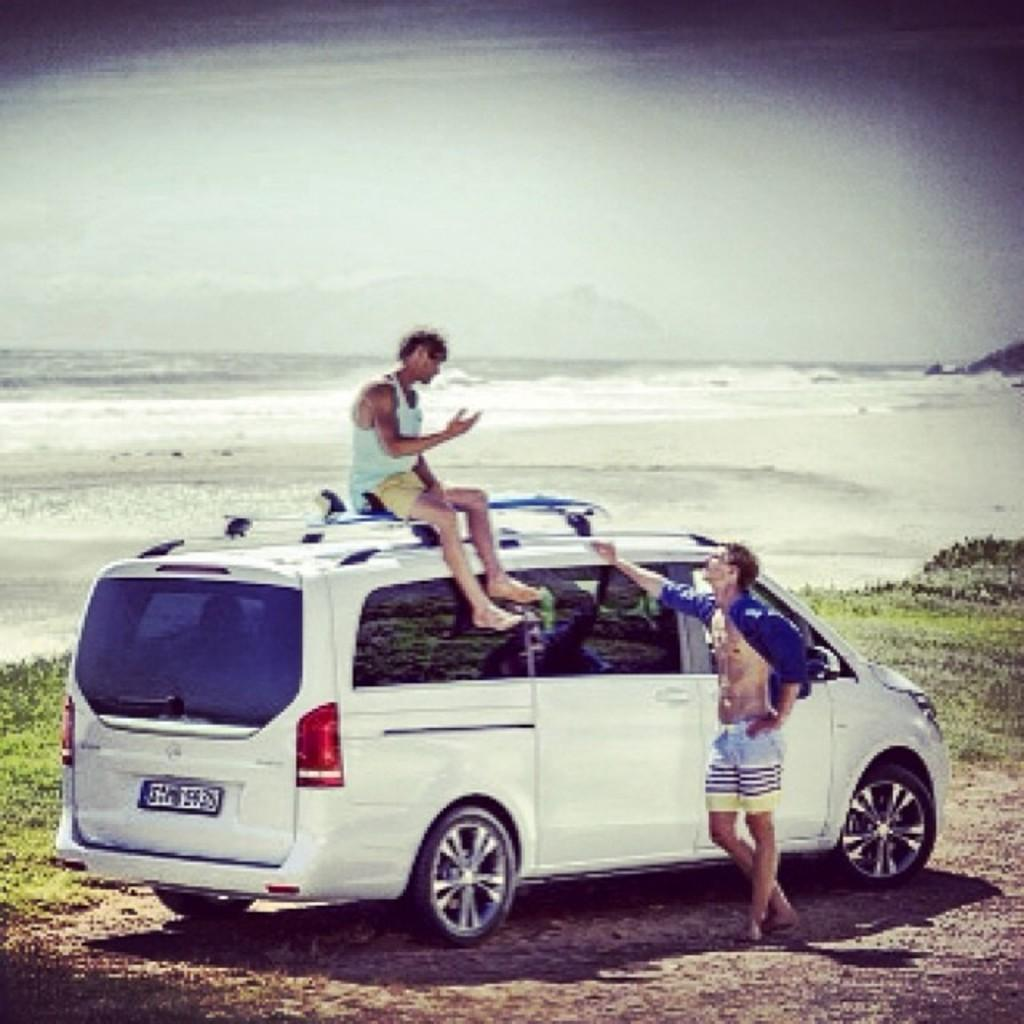How many people are in the image? There are two people in the image. What are the positions of the people in the image? One person is sitting on a car, and the other person is standing beside the car. What can be seen in the background of the image? There is a sea visible in the background of the image. What type of brick is being used to build the fog in the image? There is no brick or fog present in the image. 